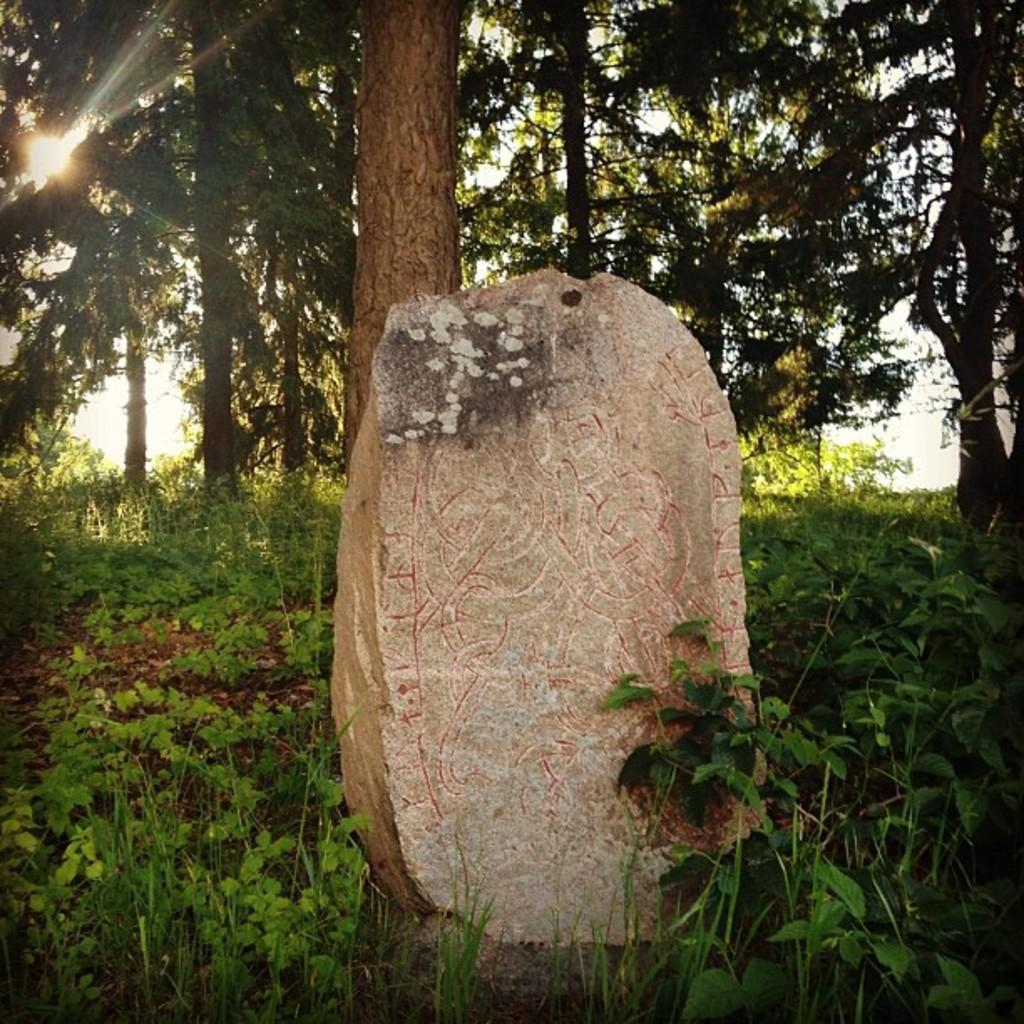Describe this image in one or two sentences. At the bottom of the picture, we see the grass and the herbs. In the middle, we see a headstone. There are trees and shrubs in the background. We even see a building in white color. In the left top, we see the sun. 